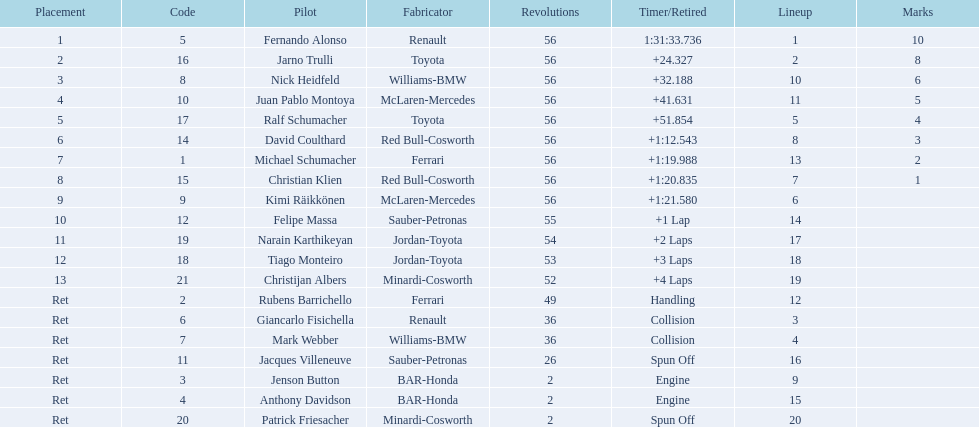Can you parse all the data within this table? {'header': ['Placement', 'Code', 'Pilot', 'Fabricator', 'Revolutions', 'Timer/Retired', 'Lineup', 'Marks'], 'rows': [['1', '5', 'Fernando Alonso', 'Renault', '56', '1:31:33.736', '1', '10'], ['2', '16', 'Jarno Trulli', 'Toyota', '56', '+24.327', '2', '8'], ['3', '8', 'Nick Heidfeld', 'Williams-BMW', '56', '+32.188', '10', '6'], ['4', '10', 'Juan Pablo Montoya', 'McLaren-Mercedes', '56', '+41.631', '11', '5'], ['5', '17', 'Ralf Schumacher', 'Toyota', '56', '+51.854', '5', '4'], ['6', '14', 'David Coulthard', 'Red Bull-Cosworth', '56', '+1:12.543', '8', '3'], ['7', '1', 'Michael Schumacher', 'Ferrari', '56', '+1:19.988', '13', '2'], ['8', '15', 'Christian Klien', 'Red Bull-Cosworth', '56', '+1:20.835', '7', '1'], ['9', '9', 'Kimi Räikkönen', 'McLaren-Mercedes', '56', '+1:21.580', '6', ''], ['10', '12', 'Felipe Massa', 'Sauber-Petronas', '55', '+1 Lap', '14', ''], ['11', '19', 'Narain Karthikeyan', 'Jordan-Toyota', '54', '+2 Laps', '17', ''], ['12', '18', 'Tiago Monteiro', 'Jordan-Toyota', '53', '+3 Laps', '18', ''], ['13', '21', 'Christijan Albers', 'Minardi-Cosworth', '52', '+4 Laps', '19', ''], ['Ret', '2', 'Rubens Barrichello', 'Ferrari', '49', 'Handling', '12', ''], ['Ret', '6', 'Giancarlo Fisichella', 'Renault', '36', 'Collision', '3', ''], ['Ret', '7', 'Mark Webber', 'Williams-BMW', '36', 'Collision', '4', ''], ['Ret', '11', 'Jacques Villeneuve', 'Sauber-Petronas', '26', 'Spun Off', '16', ''], ['Ret', '3', 'Jenson Button', 'BAR-Honda', '2', 'Engine', '9', ''], ['Ret', '4', 'Anthony Davidson', 'BAR-Honda', '2', 'Engine', '15', ''], ['Ret', '20', 'Patrick Friesacher', 'Minardi-Cosworth', '2', 'Spun Off', '20', '']]} Jarno trulli was not french but what nationality? Italian. 